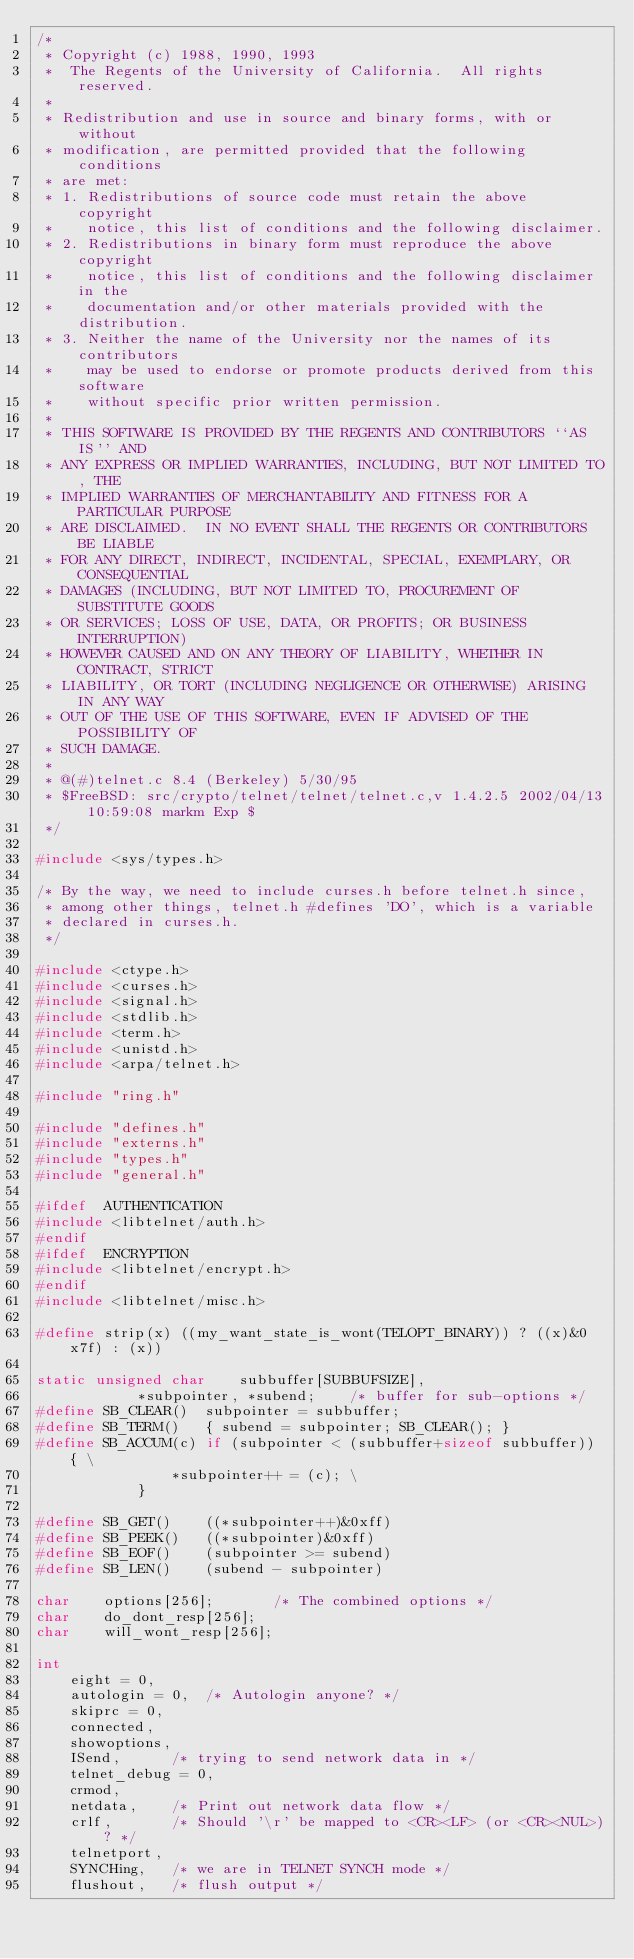Convert code to text. <code><loc_0><loc_0><loc_500><loc_500><_C_>/*
 * Copyright (c) 1988, 1990, 1993
 *	The Regents of the University of California.  All rights reserved.
 *
 * Redistribution and use in source and binary forms, with or without
 * modification, are permitted provided that the following conditions
 * are met:
 * 1. Redistributions of source code must retain the above copyright
 *    notice, this list of conditions and the following disclaimer.
 * 2. Redistributions in binary form must reproduce the above copyright
 *    notice, this list of conditions and the following disclaimer in the
 *    documentation and/or other materials provided with the distribution.
 * 3. Neither the name of the University nor the names of its contributors
 *    may be used to endorse or promote products derived from this software
 *    without specific prior written permission.
 *
 * THIS SOFTWARE IS PROVIDED BY THE REGENTS AND CONTRIBUTORS ``AS IS'' AND
 * ANY EXPRESS OR IMPLIED WARRANTIES, INCLUDING, BUT NOT LIMITED TO, THE
 * IMPLIED WARRANTIES OF MERCHANTABILITY AND FITNESS FOR A PARTICULAR PURPOSE
 * ARE DISCLAIMED.  IN NO EVENT SHALL THE REGENTS OR CONTRIBUTORS BE LIABLE
 * FOR ANY DIRECT, INDIRECT, INCIDENTAL, SPECIAL, EXEMPLARY, OR CONSEQUENTIAL
 * DAMAGES (INCLUDING, BUT NOT LIMITED TO, PROCUREMENT OF SUBSTITUTE GOODS
 * OR SERVICES; LOSS OF USE, DATA, OR PROFITS; OR BUSINESS INTERRUPTION)
 * HOWEVER CAUSED AND ON ANY THEORY OF LIABILITY, WHETHER IN CONTRACT, STRICT
 * LIABILITY, OR TORT (INCLUDING NEGLIGENCE OR OTHERWISE) ARISING IN ANY WAY
 * OUT OF THE USE OF THIS SOFTWARE, EVEN IF ADVISED OF THE POSSIBILITY OF
 * SUCH DAMAGE.
 *
 * @(#)telnet.c	8.4 (Berkeley) 5/30/95
 * $FreeBSD: src/crypto/telnet/telnet/telnet.c,v 1.4.2.5 2002/04/13 10:59:08 markm Exp $
 */

#include <sys/types.h>

/* By the way, we need to include curses.h before telnet.h since,
 * among other things, telnet.h #defines 'DO', which is a variable
 * declared in curses.h.
 */

#include <ctype.h>
#include <curses.h>
#include <signal.h>
#include <stdlib.h>
#include <term.h>
#include <unistd.h>
#include <arpa/telnet.h>

#include "ring.h"

#include "defines.h"
#include "externs.h"
#include "types.h"
#include "general.h"

#ifdef	AUTHENTICATION
#include <libtelnet/auth.h>
#endif
#ifdef	ENCRYPTION
#include <libtelnet/encrypt.h>
#endif
#include <libtelnet/misc.h>

#define	strip(x) ((my_want_state_is_wont(TELOPT_BINARY)) ? ((x)&0x7f) : (x))

static unsigned char	subbuffer[SUBBUFSIZE],
			*subpointer, *subend;	 /* buffer for sub-options */
#define	SB_CLEAR()	subpointer = subbuffer;
#define	SB_TERM()	{ subend = subpointer; SB_CLEAR(); }
#define	SB_ACCUM(c)	if (subpointer < (subbuffer+sizeof subbuffer)) { \
				*subpointer++ = (c); \
			}

#define	SB_GET()	((*subpointer++)&0xff)
#define	SB_PEEK()	((*subpointer)&0xff)
#define	SB_EOF()	(subpointer >= subend)
#define	SB_LEN()	(subend - subpointer)

char	options[256];		/* The combined options */
char	do_dont_resp[256];
char	will_wont_resp[256];

int
	eight = 0,
	autologin = 0,	/* Autologin anyone? */
	skiprc = 0,
	connected,
	showoptions,
	ISend,		/* trying to send network data in */
	telnet_debug = 0,
	crmod,
	netdata,	/* Print out network data flow */
	crlf,		/* Should '\r' be mapped to <CR><LF> (or <CR><NUL>)? */
	telnetport,
	SYNCHing,	/* we are in TELNET SYNCH mode */
	flushout,	/* flush output */</code> 